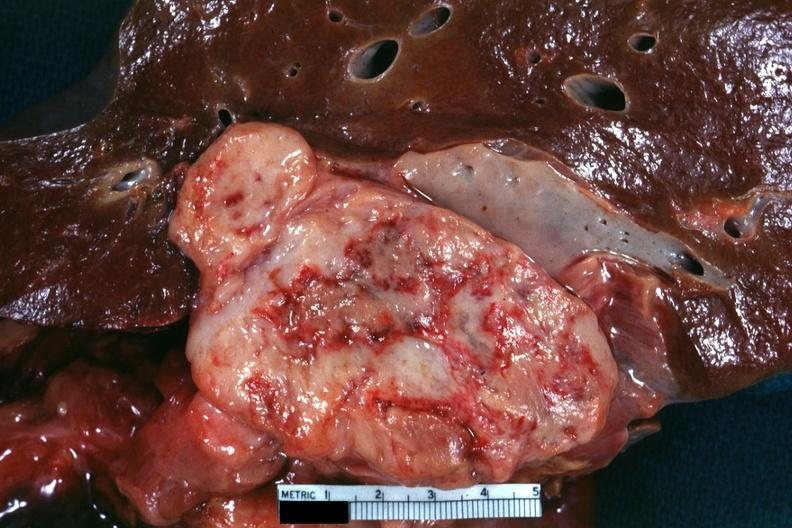s tuberculous peritonitis present?
Answer the question using a single word or phrase. No 